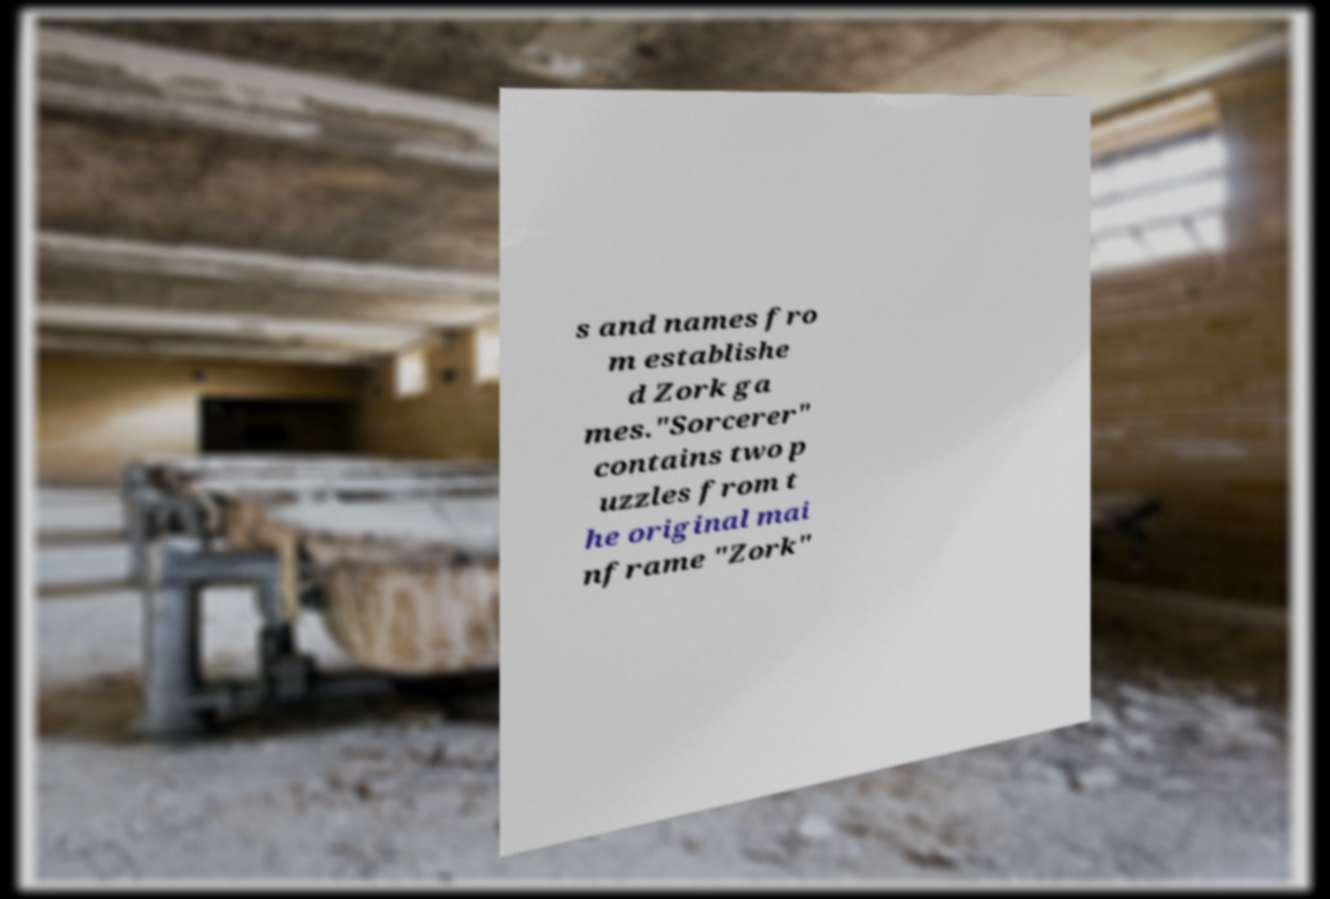Could you assist in decoding the text presented in this image and type it out clearly? s and names fro m establishe d Zork ga mes."Sorcerer" contains two p uzzles from t he original mai nframe "Zork" 